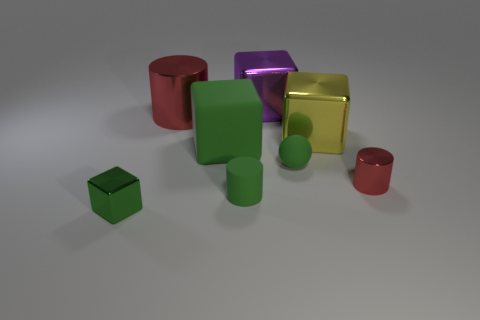There is a green cube that is on the right side of the tiny block; what number of red objects are to the left of it?
Offer a very short reply. 1. What number of other objects are the same size as the green metal block?
Give a very brief answer. 3. What size is the rubber cube that is the same color as the small sphere?
Offer a very short reply. Large. Do the tiny metallic thing that is left of the small metallic cylinder and the large yellow thing have the same shape?
Give a very brief answer. Yes. What is the material of the red cylinder that is to the right of the purple shiny block?
Offer a terse response. Metal. The large metallic object that is the same color as the tiny metal cylinder is what shape?
Ensure brevity in your answer.  Cylinder. Is there a tiny object made of the same material as the small green block?
Your answer should be compact. Yes. The yellow object has what size?
Your answer should be compact. Large. How many gray objects are either small things or big metallic objects?
Give a very brief answer. 0. What number of large gray rubber objects are the same shape as the large red object?
Your answer should be compact. 0. 